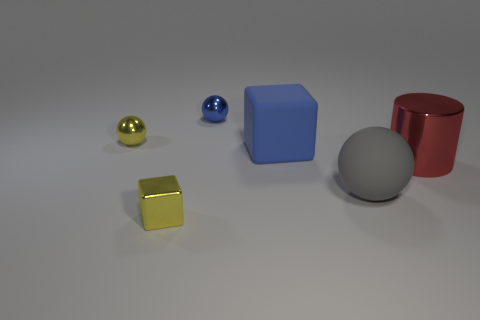There is a big gray thing that is the same shape as the small blue object; what material is it?
Keep it short and to the point. Rubber. Is there a blue object that is in front of the small metallic sphere to the left of the cube left of the small blue metal ball?
Keep it short and to the point. Yes. There is a big gray rubber object; is its shape the same as the yellow thing that is in front of the big ball?
Provide a short and direct response. No. Is there any other thing that has the same color as the large shiny cylinder?
Offer a very short reply. No. There is a large matte object behind the cylinder; is its color the same as the tiny metal ball that is right of the small yellow shiny ball?
Make the answer very short. Yes. Are any green cylinders visible?
Your answer should be compact. No. Is there a blue thing that has the same material as the big cylinder?
Keep it short and to the point. Yes. The rubber ball is what color?
Provide a succinct answer. Gray. The tiny thing that is the same color as the matte block is what shape?
Ensure brevity in your answer.  Sphere. The rubber thing that is the same size as the rubber block is what color?
Provide a succinct answer. Gray. 